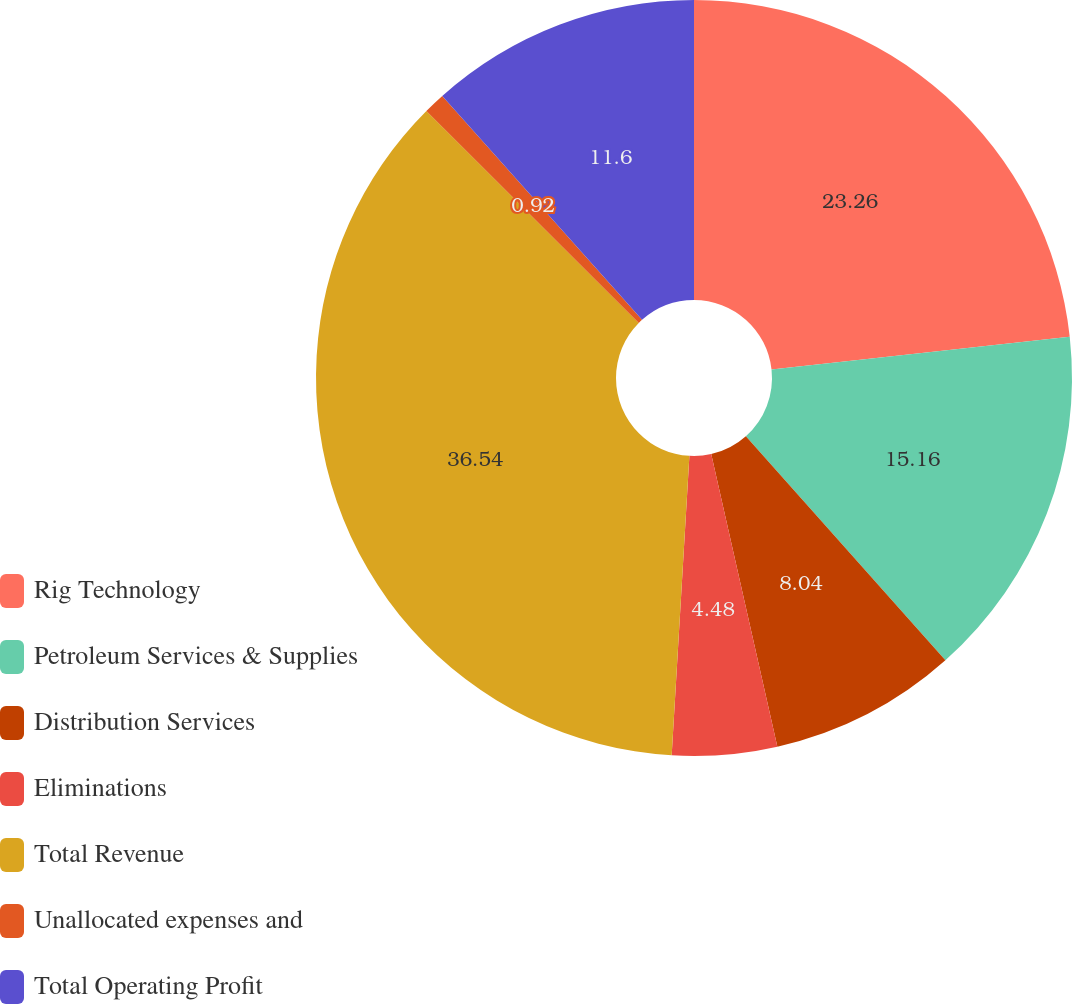Convert chart to OTSL. <chart><loc_0><loc_0><loc_500><loc_500><pie_chart><fcel>Rig Technology<fcel>Petroleum Services & Supplies<fcel>Distribution Services<fcel>Eliminations<fcel>Total Revenue<fcel>Unallocated expenses and<fcel>Total Operating Profit<nl><fcel>23.26%<fcel>15.16%<fcel>8.04%<fcel>4.48%<fcel>36.54%<fcel>0.92%<fcel>11.6%<nl></chart> 